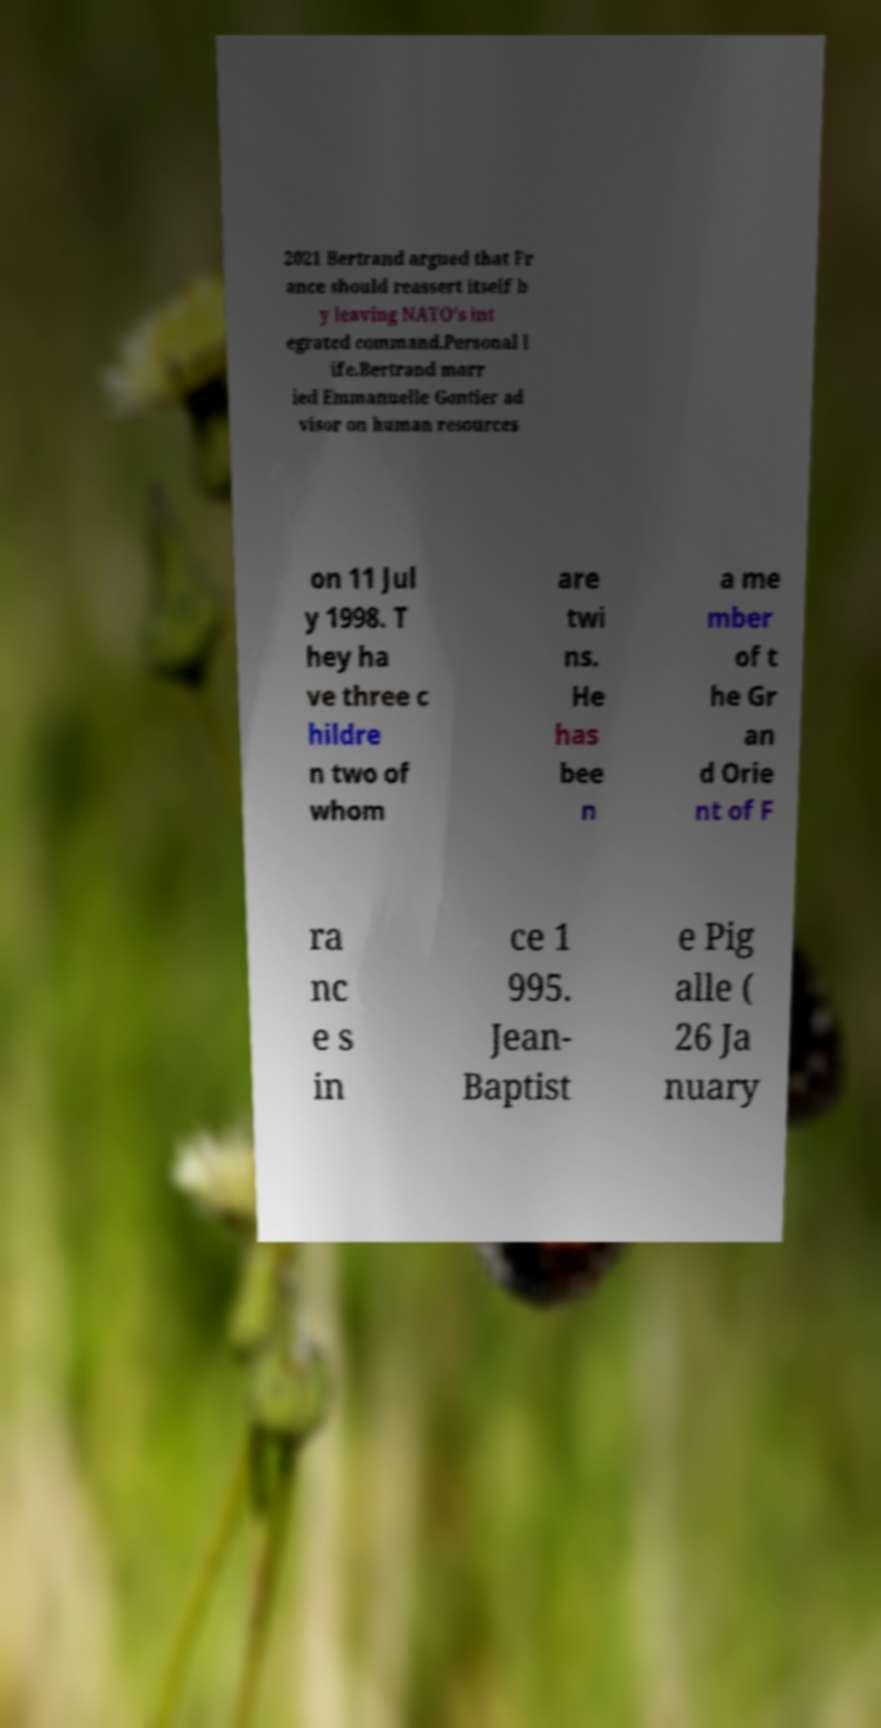Can you accurately transcribe the text from the provided image for me? 2021 Bertrand argued that Fr ance should reassert itself b y leaving NATO’s int egrated command.Personal l ife.Bertrand marr ied Emmanuelle Gontier ad visor on human resources on 11 Jul y 1998. T hey ha ve three c hildre n two of whom are twi ns. He has bee n a me mber of t he Gr an d Orie nt of F ra nc e s in ce 1 995. Jean- Baptist e Pig alle ( 26 Ja nuary 